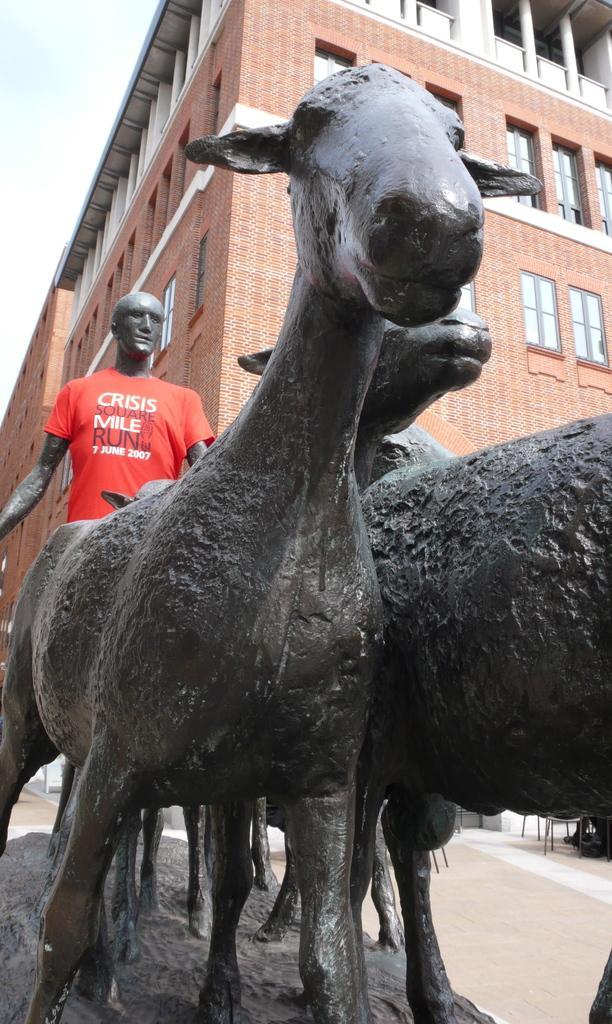Can you describe this image briefly? In this image I can see statues of three animals and a person's on the road. In the background I can see chairs, buildings, windows and the sky. This image is taken may be during a day. 